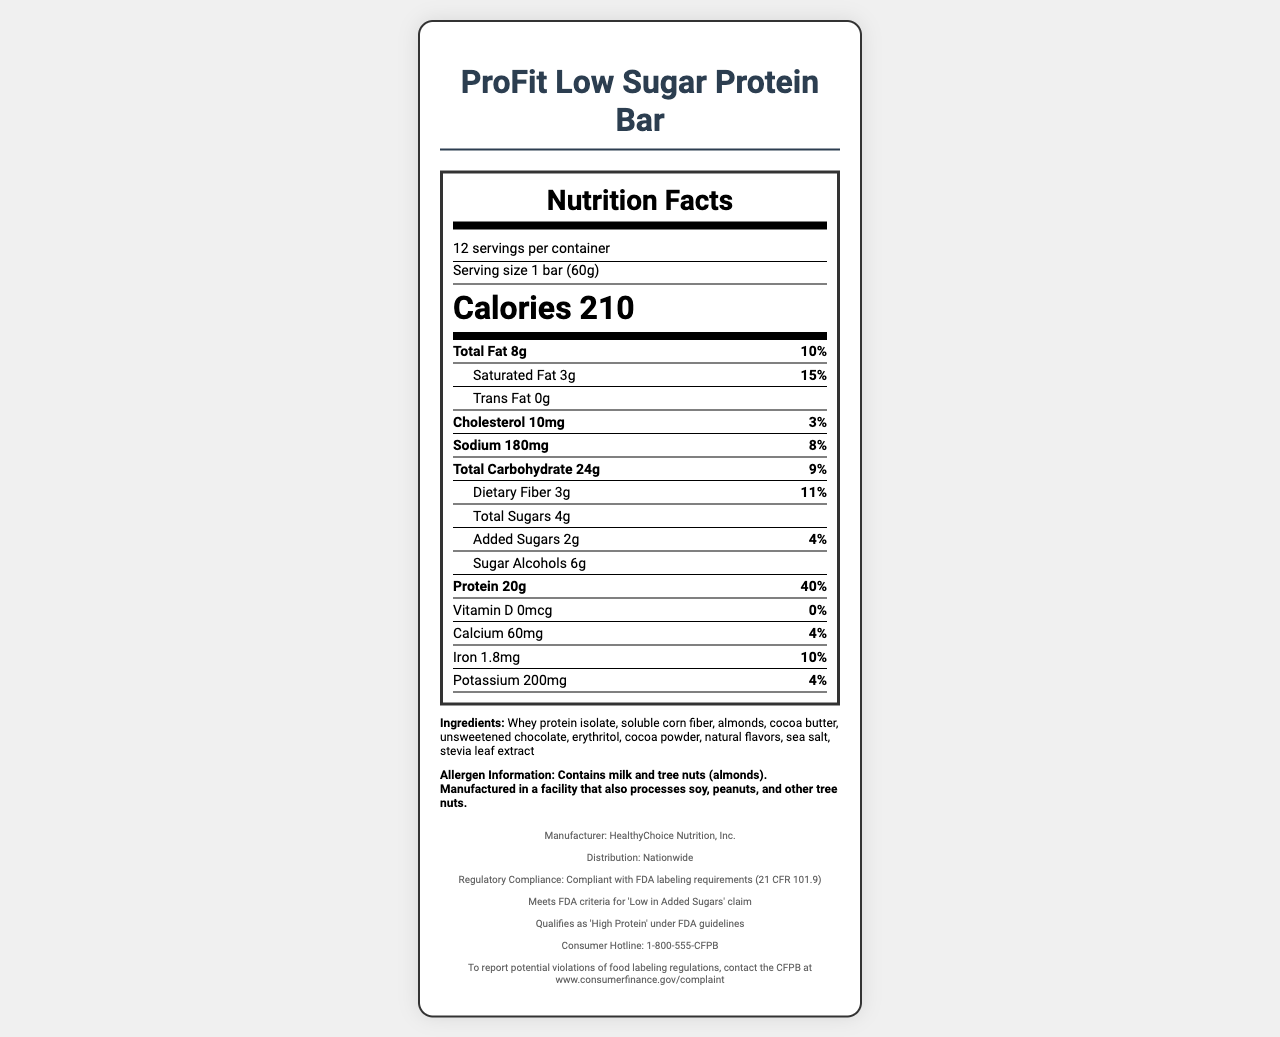what is the serving size? The serving size is clearly mentioned at the beginning along with other serving details as "Serving size 1 bar (60g)".
Answer: 1 bar (60g) how many servings are in the container? The document states "12 servings per container" at the beginning.
Answer: 12 how many calories are in one serving? The number of calories is prominently displayed as "Calories 210".
Answer: 210 what is the amount of added sugars in the bar? The document lists "Added Sugars 2g" under the sugars section.
Answer: 2g what ingredients are in the protein bar? The ingredients are listed at the end of the label in the ingredients section.
Answer: Whey protein isolate, soluble corn fiber, almonds, cocoa butter, unsweetened chocolate, erythritol, cocoa powder, natural flavors, sea salt, stevia leaf extract which organization can you contact to report violations? The footer states "To report potential violations of food labeling regulations, contact the CFPB at www.consumerfinance.gov/complaint".
Answer: CFPB how much protein does one bar contain? Under the nutrients section, it mentions "Protein 20g" with a daily value of 40%.
Answer: 20g what is the percent daily value of saturated fat? The percent daily value of saturated fat is 15% as indicated in the document.
Answer: 15% how much sodium is in the protein bar? A. 100mg B. 180mg C. 200mg D. 150mg The nutrient section shows "Sodium 180mg".
Answer: B which of the following claims does the protein bar meet according to the FDA? I. Low in Added Sugars II. High Fiber III. High Protein Under the regulatory compliance section, it states that it meets "Low in Added Sugars" and "High Protein" but does not mention "High Fiber".
Answer: I and III does the label comply with FDA labeling requirements? The footer mentions "Compliant with FDA labeling requirements (21 CFR 101.9)".
Answer: Yes does the protein bar contain any trans fat? The label specifies "Trans Fat 0g".
Answer: No summarize the main points of the nutrition label and compliance information. This summary covers the main nutritional content, regulatory compliance, and additional details like ingredients, manufacturer, and distribution.
Answer: The ProFit Low Sugar Protein Bar has 210 calories per serving with 8g of total fat, 24g of total carbohydrates, and 20g of protein. It contains 2g of added sugars and is compliant with FDA regulations, meeting criteria for "Low in Added Sugars" and "High Protein". It includes ingredients like whey protein isolate and almonds and provides allergen information. The manufacturer is HealthyChoice Nutrition, Inc., and the product is distributed nationwide. how much fiber does the bar provide? The document states "Dietary Fiber 3g" under the carbohydrate section.
Answer: 3g who is the manufacturer of the protein bar? The manufacturer's name is at the footer of the document.
Answer: HealthyChoice Nutrition, Inc. does this product naturally contain tree nuts? The allergen information section lists almonds as one of the ingredients, indicating that it does contain tree nuts.
Answer: Yes what is the contact number for the consumer hotline? The footer provides the consumer hotline number as "1-800-555-CFPB".
Answer: 1-800-555-CFPB is there any information about the cost of the protein bar? The document does not provide any details regarding the cost or pricing of the protein bar.
Answer: Not enough information 